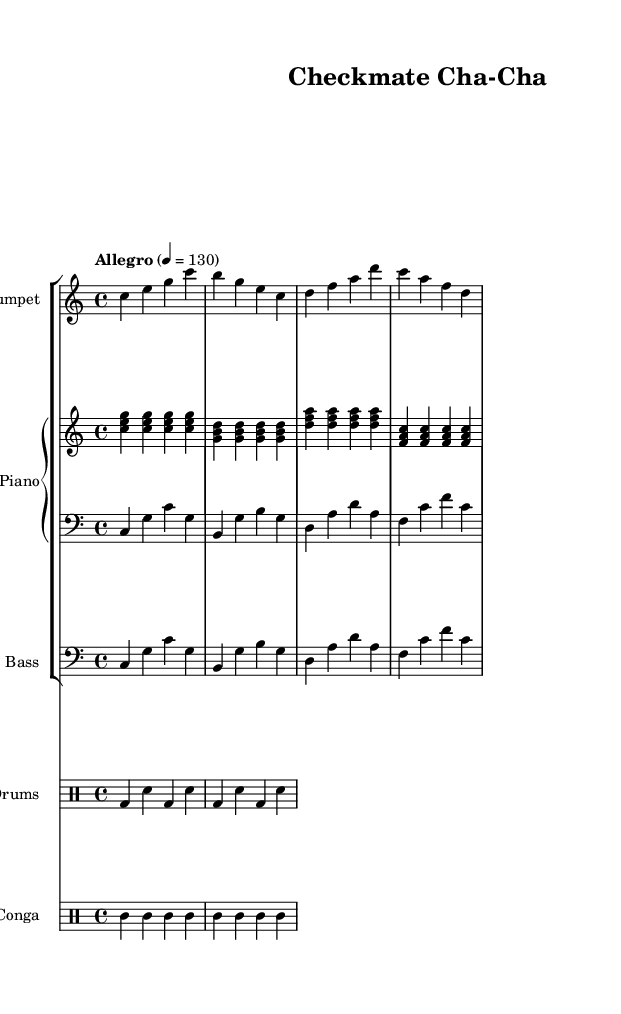What is the key signature of this music? The key signature is C major, which has no sharps or flats.
Answer: C major What is the time signature of this music? The time signature is indicated as 4/4, meaning there are four beats per measure.
Answer: 4/4 What is the tempo marking for this piece? The tempo marking is "Allegro" with a metronome marking of 130 beats per minute, suggesting a fast pace.
Answer: Allegro How many measures are in the trumpet part? To find the number of measures, count the groups of notes in the trumpet part. There are 4 measures in total.
Answer: 4 What type of rhythm is predominantly used in the drums part? The drums part primarily uses a basic alternating pattern with bass drums and snare, creating a regular rhythm typical in Latin jazz.
Answer: Alternating pattern Which instrument contributes to the harmonic support in this piece? The piano provides harmonic support, as it plays chords along with the melody.
Answer: Piano What dynamic level is suggested by the choice of "Allegro"? The term "Allegro" typically suggests a lively and bright dynamic level, which encourages energetic playing.
Answer: Lively 